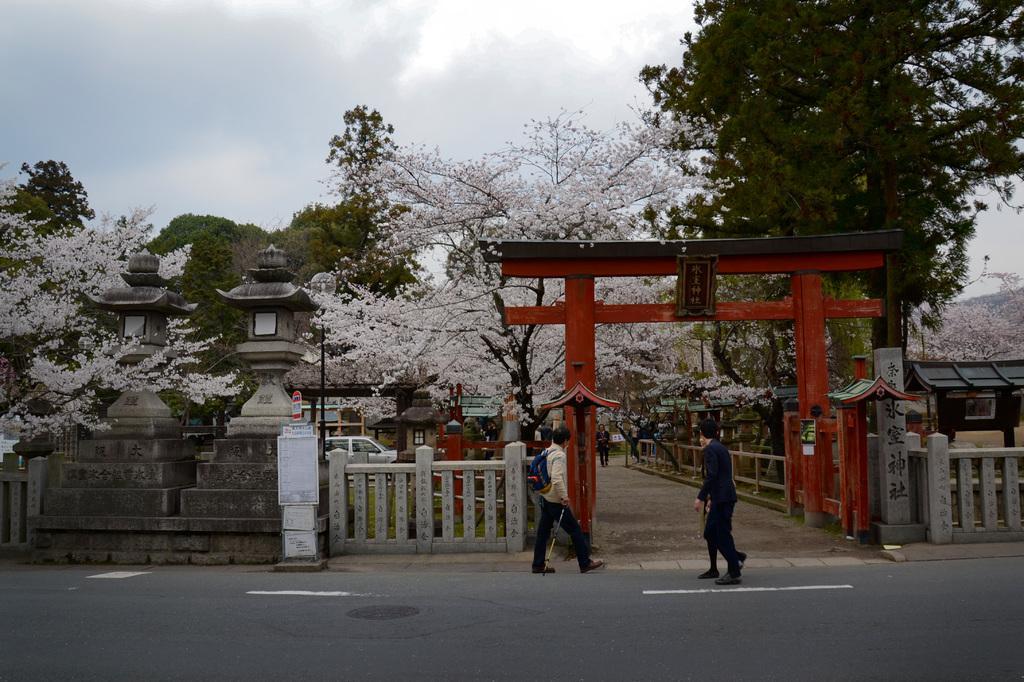How would you summarize this image in a sentence or two? In this image, we can see trees, sheds, an arch and some people, one of them is wearing a bag and holding a stick and we can see fences, boards and some plants. At the top, there are clouds in the sky and at the bottom, there is a road. 